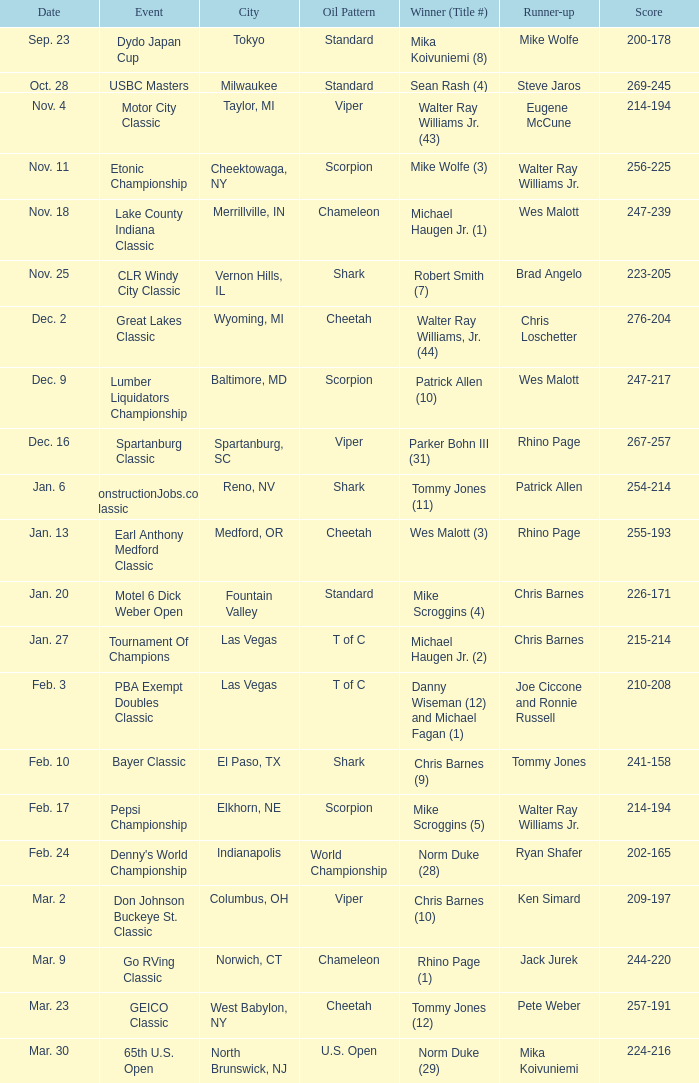Would you mind parsing the complete table? {'header': ['Date', 'Event', 'City', 'Oil Pattern', 'Winner (Title #)', 'Runner-up', 'Score'], 'rows': [['Sep. 23', 'Dydo Japan Cup', 'Tokyo', 'Standard', 'Mika Koivuniemi (8)', 'Mike Wolfe', '200-178'], ['Oct. 28', 'USBC Masters', 'Milwaukee', 'Standard', 'Sean Rash (4)', 'Steve Jaros', '269-245'], ['Nov. 4', 'Motor City Classic', 'Taylor, MI', 'Viper', 'Walter Ray Williams Jr. (43)', 'Eugene McCune', '214-194'], ['Nov. 11', 'Etonic Championship', 'Cheektowaga, NY', 'Scorpion', 'Mike Wolfe (3)', 'Walter Ray Williams Jr.', '256-225'], ['Nov. 18', 'Lake County Indiana Classic', 'Merrillville, IN', 'Chameleon', 'Michael Haugen Jr. (1)', 'Wes Malott', '247-239'], ['Nov. 25', 'CLR Windy City Classic', 'Vernon Hills, IL', 'Shark', 'Robert Smith (7)', 'Brad Angelo', '223-205'], ['Dec. 2', 'Great Lakes Classic', 'Wyoming, MI', 'Cheetah', 'Walter Ray Williams, Jr. (44)', 'Chris Loschetter', '276-204'], ['Dec. 9', 'Lumber Liquidators Championship', 'Baltimore, MD', 'Scorpion', 'Patrick Allen (10)', 'Wes Malott', '247-217'], ['Dec. 16', 'Spartanburg Classic', 'Spartanburg, SC', 'Viper', 'Parker Bohn III (31)', 'Rhino Page', '267-257'], ['Jan. 6', 'ConstructionJobs.com Classic', 'Reno, NV', 'Shark', 'Tommy Jones (11)', 'Patrick Allen', '254-214'], ['Jan. 13', 'Earl Anthony Medford Classic', 'Medford, OR', 'Cheetah', 'Wes Malott (3)', 'Rhino Page', '255-193'], ['Jan. 20', 'Motel 6 Dick Weber Open', 'Fountain Valley', 'Standard', 'Mike Scroggins (4)', 'Chris Barnes', '226-171'], ['Jan. 27', 'Tournament Of Champions', 'Las Vegas', 'T of C', 'Michael Haugen Jr. (2)', 'Chris Barnes', '215-214'], ['Feb. 3', 'PBA Exempt Doubles Classic', 'Las Vegas', 'T of C', 'Danny Wiseman (12) and Michael Fagan (1)', 'Joe Ciccone and Ronnie Russell', '210-208'], ['Feb. 10', 'Bayer Classic', 'El Paso, TX', 'Shark', 'Chris Barnes (9)', 'Tommy Jones', '241-158'], ['Feb. 17', 'Pepsi Championship', 'Elkhorn, NE', 'Scorpion', 'Mike Scroggins (5)', 'Walter Ray Williams Jr.', '214-194'], ['Feb. 24', "Denny's World Championship", 'Indianapolis', 'World Championship', 'Norm Duke (28)', 'Ryan Shafer', '202-165'], ['Mar. 2', 'Don Johnson Buckeye St. Classic', 'Columbus, OH', 'Viper', 'Chris Barnes (10)', 'Ken Simard', '209-197'], ['Mar. 9', 'Go RVing Classic', 'Norwich, CT', 'Chameleon', 'Rhino Page (1)', 'Jack Jurek', '244-220'], ['Mar. 23', 'GEICO Classic', 'West Babylon, NY', 'Cheetah', 'Tommy Jones (12)', 'Pete Weber', '257-191'], ['Mar. 30', '65th U.S. Open', 'North Brunswick, NJ', 'U.S. Open', 'Norm Duke (29)', 'Mika Koivuniemi', '224-216']]} Name the Event which has a Winner (Title #) of parker bohn iii (31)? Spartanburg Classic. 